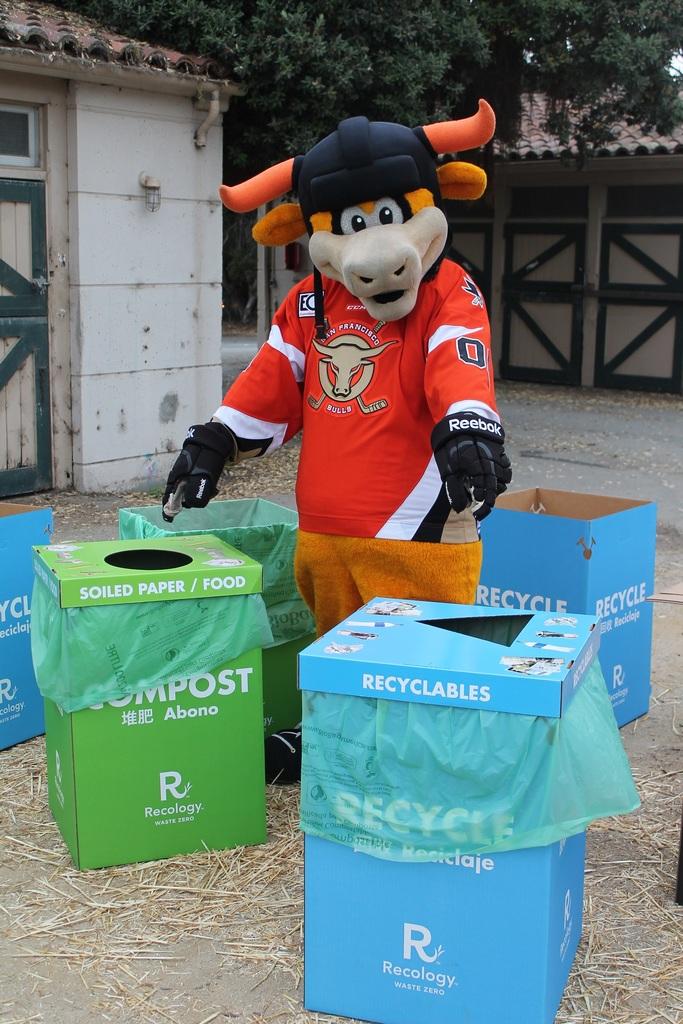That's on the green trash can?
Your answer should be very brief. Compost. What goes in the blue boxes?
Your answer should be very brief. Recyclables. 